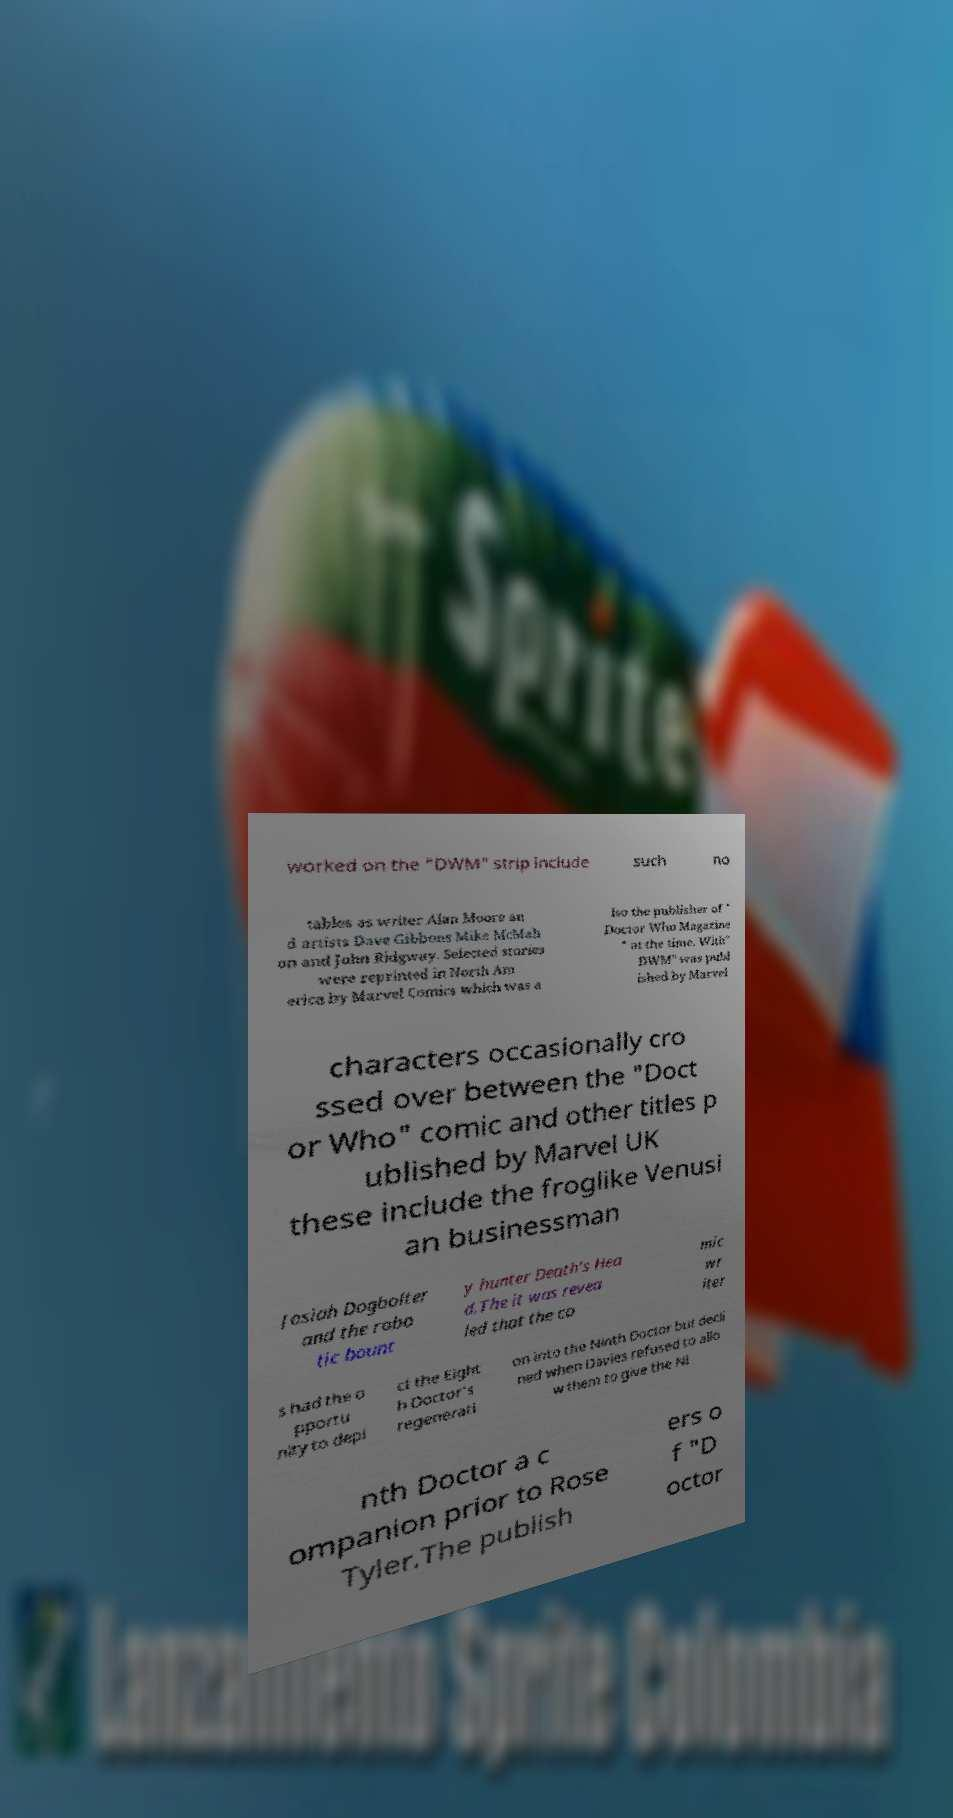For documentation purposes, I need the text within this image transcribed. Could you provide that? worked on the "DWM" strip include such no tables as writer Alan Moore an d artists Dave Gibbons Mike McMah on and John Ridgway. Selected stories were reprinted in North Am erica by Marvel Comics which was a lso the publisher of " Doctor Who Magazine " at the time. With" DWM" was publ ished by Marvel characters occasionally cro ssed over between the "Doct or Who" comic and other titles p ublished by Marvel UK these include the froglike Venusi an businessman Josiah Dogbolter and the robo tic bount y hunter Death's Hea d.The it was revea led that the co mic wr iter s had the o pportu nity to depi ct the Eight h Doctor's regenerati on into the Ninth Doctor but decli ned when Davies refused to allo w them to give the Ni nth Doctor a c ompanion prior to Rose Tyler.The publish ers o f "D octor 